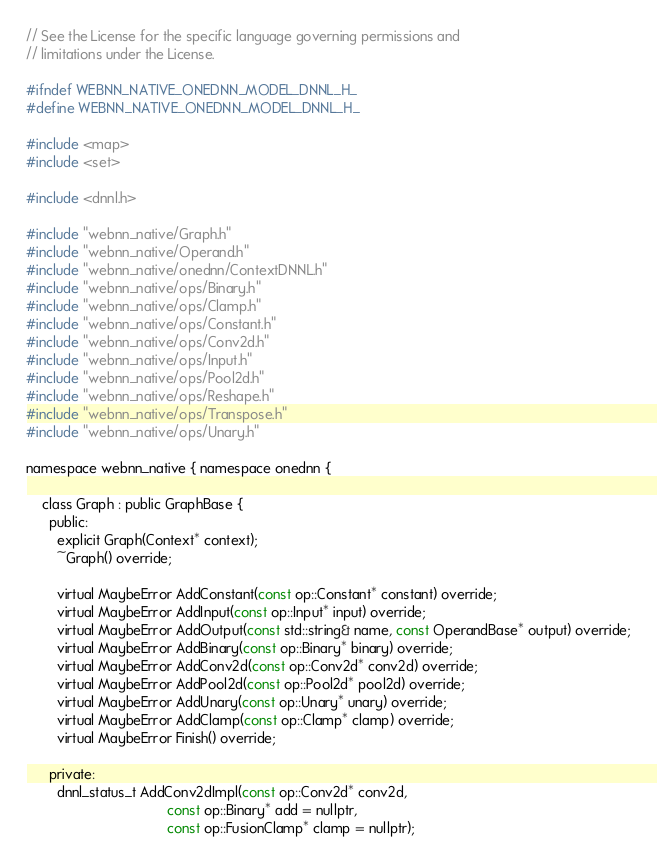<code> <loc_0><loc_0><loc_500><loc_500><_C_>// See the License for the specific language governing permissions and
// limitations under the License.

#ifndef WEBNN_NATIVE_ONEDNN_MODEL_DNNL_H_
#define WEBNN_NATIVE_ONEDNN_MODEL_DNNL_H_

#include <map>
#include <set>

#include <dnnl.h>

#include "webnn_native/Graph.h"
#include "webnn_native/Operand.h"
#include "webnn_native/onednn/ContextDNNL.h"
#include "webnn_native/ops/Binary.h"
#include "webnn_native/ops/Clamp.h"
#include "webnn_native/ops/Constant.h"
#include "webnn_native/ops/Conv2d.h"
#include "webnn_native/ops/Input.h"
#include "webnn_native/ops/Pool2d.h"
#include "webnn_native/ops/Reshape.h"
#include "webnn_native/ops/Transpose.h"
#include "webnn_native/ops/Unary.h"

namespace webnn_native { namespace onednn {

    class Graph : public GraphBase {
      public:
        explicit Graph(Context* context);
        ~Graph() override;

        virtual MaybeError AddConstant(const op::Constant* constant) override;
        virtual MaybeError AddInput(const op::Input* input) override;
        virtual MaybeError AddOutput(const std::string& name, const OperandBase* output) override;
        virtual MaybeError AddBinary(const op::Binary* binary) override;
        virtual MaybeError AddConv2d(const op::Conv2d* conv2d) override;
        virtual MaybeError AddPool2d(const op::Pool2d* pool2d) override;
        virtual MaybeError AddUnary(const op::Unary* unary) override;
        virtual MaybeError AddClamp(const op::Clamp* clamp) override;
        virtual MaybeError Finish() override;

      private:
        dnnl_status_t AddConv2dImpl(const op::Conv2d* conv2d,
                                    const op::Binary* add = nullptr,
                                    const op::FusionClamp* clamp = nullptr);</code> 